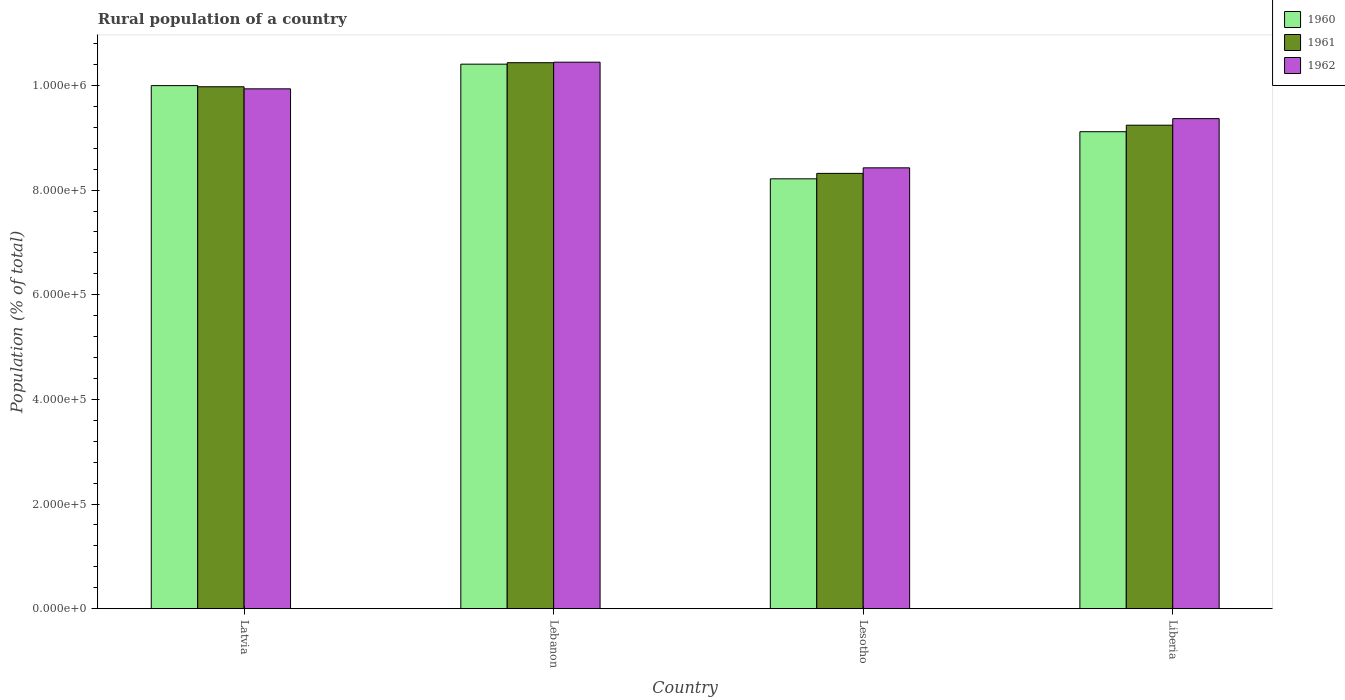How many bars are there on the 2nd tick from the right?
Make the answer very short. 3. What is the label of the 4th group of bars from the left?
Your response must be concise. Liberia. What is the rural population in 1962 in Lebanon?
Give a very brief answer. 1.04e+06. Across all countries, what is the maximum rural population in 1961?
Offer a very short reply. 1.04e+06. Across all countries, what is the minimum rural population in 1961?
Your answer should be very brief. 8.32e+05. In which country was the rural population in 1962 maximum?
Your response must be concise. Lebanon. In which country was the rural population in 1961 minimum?
Give a very brief answer. Lesotho. What is the total rural population in 1962 in the graph?
Provide a succinct answer. 3.82e+06. What is the difference between the rural population in 1961 in Lebanon and that in Liberia?
Offer a terse response. 1.19e+05. What is the difference between the rural population in 1961 in Latvia and the rural population in 1962 in Lebanon?
Offer a terse response. -4.69e+04. What is the average rural population in 1960 per country?
Keep it short and to the point. 9.43e+05. What is the difference between the rural population of/in 1962 and rural population of/in 1961 in Liberia?
Offer a terse response. 1.25e+04. What is the ratio of the rural population in 1960 in Latvia to that in Liberia?
Your response must be concise. 1.1. What is the difference between the highest and the second highest rural population in 1962?
Your response must be concise. 5.09e+04. What is the difference between the highest and the lowest rural population in 1960?
Provide a succinct answer. 2.19e+05. What does the 2nd bar from the left in Latvia represents?
Keep it short and to the point. 1961. What does the 2nd bar from the right in Lesotho represents?
Make the answer very short. 1961. Is it the case that in every country, the sum of the rural population in 1961 and rural population in 1962 is greater than the rural population in 1960?
Your answer should be compact. Yes. How many countries are there in the graph?
Offer a terse response. 4. Where does the legend appear in the graph?
Provide a succinct answer. Top right. How many legend labels are there?
Your answer should be compact. 3. What is the title of the graph?
Offer a terse response. Rural population of a country. Does "2009" appear as one of the legend labels in the graph?
Offer a terse response. No. What is the label or title of the Y-axis?
Your answer should be compact. Population (% of total). What is the Population (% of total) in 1960 in Latvia?
Make the answer very short. 1.00e+06. What is the Population (% of total) in 1961 in Latvia?
Your response must be concise. 9.97e+05. What is the Population (% of total) of 1962 in Latvia?
Provide a succinct answer. 9.94e+05. What is the Population (% of total) of 1960 in Lebanon?
Your answer should be very brief. 1.04e+06. What is the Population (% of total) in 1961 in Lebanon?
Provide a short and direct response. 1.04e+06. What is the Population (% of total) of 1962 in Lebanon?
Give a very brief answer. 1.04e+06. What is the Population (% of total) of 1960 in Lesotho?
Offer a very short reply. 8.22e+05. What is the Population (% of total) of 1961 in Lesotho?
Your answer should be very brief. 8.32e+05. What is the Population (% of total) of 1962 in Lesotho?
Make the answer very short. 8.43e+05. What is the Population (% of total) of 1960 in Liberia?
Ensure brevity in your answer.  9.12e+05. What is the Population (% of total) of 1961 in Liberia?
Your answer should be very brief. 9.24e+05. What is the Population (% of total) of 1962 in Liberia?
Offer a very short reply. 9.37e+05. Across all countries, what is the maximum Population (% of total) of 1960?
Keep it short and to the point. 1.04e+06. Across all countries, what is the maximum Population (% of total) of 1961?
Ensure brevity in your answer.  1.04e+06. Across all countries, what is the maximum Population (% of total) in 1962?
Make the answer very short. 1.04e+06. Across all countries, what is the minimum Population (% of total) in 1960?
Keep it short and to the point. 8.22e+05. Across all countries, what is the minimum Population (% of total) of 1961?
Your response must be concise. 8.32e+05. Across all countries, what is the minimum Population (% of total) of 1962?
Provide a succinct answer. 8.43e+05. What is the total Population (% of total) in 1960 in the graph?
Provide a short and direct response. 3.77e+06. What is the total Population (% of total) in 1961 in the graph?
Offer a terse response. 3.80e+06. What is the total Population (% of total) of 1962 in the graph?
Provide a short and direct response. 3.82e+06. What is the difference between the Population (% of total) in 1960 in Latvia and that in Lebanon?
Provide a short and direct response. -4.10e+04. What is the difference between the Population (% of total) of 1961 in Latvia and that in Lebanon?
Provide a succinct answer. -4.60e+04. What is the difference between the Population (% of total) of 1962 in Latvia and that in Lebanon?
Offer a terse response. -5.09e+04. What is the difference between the Population (% of total) in 1960 in Latvia and that in Lesotho?
Provide a short and direct response. 1.78e+05. What is the difference between the Population (% of total) in 1961 in Latvia and that in Lesotho?
Offer a terse response. 1.66e+05. What is the difference between the Population (% of total) in 1962 in Latvia and that in Lesotho?
Your answer should be compact. 1.51e+05. What is the difference between the Population (% of total) of 1960 in Latvia and that in Liberia?
Offer a terse response. 8.81e+04. What is the difference between the Population (% of total) in 1961 in Latvia and that in Liberia?
Keep it short and to the point. 7.35e+04. What is the difference between the Population (% of total) of 1962 in Latvia and that in Liberia?
Your response must be concise. 5.69e+04. What is the difference between the Population (% of total) of 1960 in Lebanon and that in Lesotho?
Offer a very short reply. 2.19e+05. What is the difference between the Population (% of total) of 1961 in Lebanon and that in Lesotho?
Provide a short and direct response. 2.12e+05. What is the difference between the Population (% of total) of 1962 in Lebanon and that in Lesotho?
Offer a terse response. 2.02e+05. What is the difference between the Population (% of total) of 1960 in Lebanon and that in Liberia?
Make the answer very short. 1.29e+05. What is the difference between the Population (% of total) of 1961 in Lebanon and that in Liberia?
Offer a terse response. 1.19e+05. What is the difference between the Population (% of total) in 1962 in Lebanon and that in Liberia?
Offer a terse response. 1.08e+05. What is the difference between the Population (% of total) in 1960 in Lesotho and that in Liberia?
Keep it short and to the point. -9.01e+04. What is the difference between the Population (% of total) in 1961 in Lesotho and that in Liberia?
Give a very brief answer. -9.21e+04. What is the difference between the Population (% of total) of 1962 in Lesotho and that in Liberia?
Keep it short and to the point. -9.40e+04. What is the difference between the Population (% of total) of 1960 in Latvia and the Population (% of total) of 1961 in Lebanon?
Offer a terse response. -4.38e+04. What is the difference between the Population (% of total) in 1960 in Latvia and the Population (% of total) in 1962 in Lebanon?
Your response must be concise. -4.47e+04. What is the difference between the Population (% of total) in 1961 in Latvia and the Population (% of total) in 1962 in Lebanon?
Your response must be concise. -4.69e+04. What is the difference between the Population (% of total) in 1960 in Latvia and the Population (% of total) in 1961 in Lesotho?
Ensure brevity in your answer.  1.68e+05. What is the difference between the Population (% of total) of 1960 in Latvia and the Population (% of total) of 1962 in Lesotho?
Ensure brevity in your answer.  1.57e+05. What is the difference between the Population (% of total) in 1961 in Latvia and the Population (% of total) in 1962 in Lesotho?
Ensure brevity in your answer.  1.55e+05. What is the difference between the Population (% of total) of 1960 in Latvia and the Population (% of total) of 1961 in Liberia?
Make the answer very short. 7.56e+04. What is the difference between the Population (% of total) in 1960 in Latvia and the Population (% of total) in 1962 in Liberia?
Provide a short and direct response. 6.31e+04. What is the difference between the Population (% of total) in 1961 in Latvia and the Population (% of total) in 1962 in Liberia?
Offer a terse response. 6.09e+04. What is the difference between the Population (% of total) in 1960 in Lebanon and the Population (% of total) in 1961 in Lesotho?
Provide a succinct answer. 2.09e+05. What is the difference between the Population (% of total) of 1960 in Lebanon and the Population (% of total) of 1962 in Lesotho?
Provide a succinct answer. 1.98e+05. What is the difference between the Population (% of total) of 1961 in Lebanon and the Population (% of total) of 1962 in Lesotho?
Keep it short and to the point. 2.01e+05. What is the difference between the Population (% of total) of 1960 in Lebanon and the Population (% of total) of 1961 in Liberia?
Make the answer very short. 1.17e+05. What is the difference between the Population (% of total) of 1960 in Lebanon and the Population (% of total) of 1962 in Liberia?
Your answer should be compact. 1.04e+05. What is the difference between the Population (% of total) of 1961 in Lebanon and the Population (% of total) of 1962 in Liberia?
Provide a short and direct response. 1.07e+05. What is the difference between the Population (% of total) of 1960 in Lesotho and the Population (% of total) of 1961 in Liberia?
Your response must be concise. -1.03e+05. What is the difference between the Population (% of total) in 1960 in Lesotho and the Population (% of total) in 1962 in Liberia?
Give a very brief answer. -1.15e+05. What is the difference between the Population (% of total) of 1961 in Lesotho and the Population (% of total) of 1962 in Liberia?
Make the answer very short. -1.05e+05. What is the average Population (% of total) in 1960 per country?
Provide a short and direct response. 9.43e+05. What is the average Population (% of total) in 1961 per country?
Keep it short and to the point. 9.49e+05. What is the average Population (% of total) in 1962 per country?
Ensure brevity in your answer.  9.54e+05. What is the difference between the Population (% of total) in 1960 and Population (% of total) in 1961 in Latvia?
Offer a very short reply. 2193. What is the difference between the Population (% of total) in 1960 and Population (% of total) in 1962 in Latvia?
Your answer should be compact. 6165. What is the difference between the Population (% of total) in 1961 and Population (% of total) in 1962 in Latvia?
Make the answer very short. 3972. What is the difference between the Population (% of total) of 1960 and Population (% of total) of 1961 in Lebanon?
Your answer should be compact. -2785. What is the difference between the Population (% of total) of 1960 and Population (% of total) of 1962 in Lebanon?
Your answer should be very brief. -3757. What is the difference between the Population (% of total) in 1961 and Population (% of total) in 1962 in Lebanon?
Provide a short and direct response. -972. What is the difference between the Population (% of total) in 1960 and Population (% of total) in 1961 in Lesotho?
Provide a short and direct response. -1.04e+04. What is the difference between the Population (% of total) in 1960 and Population (% of total) in 1962 in Lesotho?
Your answer should be compact. -2.10e+04. What is the difference between the Population (% of total) in 1961 and Population (% of total) in 1962 in Lesotho?
Your answer should be compact. -1.06e+04. What is the difference between the Population (% of total) of 1960 and Population (% of total) of 1961 in Liberia?
Keep it short and to the point. -1.25e+04. What is the difference between the Population (% of total) in 1960 and Population (% of total) in 1962 in Liberia?
Your answer should be compact. -2.50e+04. What is the difference between the Population (% of total) of 1961 and Population (% of total) of 1962 in Liberia?
Offer a terse response. -1.25e+04. What is the ratio of the Population (% of total) of 1960 in Latvia to that in Lebanon?
Offer a terse response. 0.96. What is the ratio of the Population (% of total) of 1961 in Latvia to that in Lebanon?
Provide a succinct answer. 0.96. What is the ratio of the Population (% of total) in 1962 in Latvia to that in Lebanon?
Give a very brief answer. 0.95. What is the ratio of the Population (% of total) of 1960 in Latvia to that in Lesotho?
Your answer should be very brief. 1.22. What is the ratio of the Population (% of total) of 1961 in Latvia to that in Lesotho?
Provide a succinct answer. 1.2. What is the ratio of the Population (% of total) of 1962 in Latvia to that in Lesotho?
Provide a short and direct response. 1.18. What is the ratio of the Population (% of total) of 1960 in Latvia to that in Liberia?
Offer a terse response. 1.1. What is the ratio of the Population (% of total) in 1961 in Latvia to that in Liberia?
Your answer should be very brief. 1.08. What is the ratio of the Population (% of total) in 1962 in Latvia to that in Liberia?
Keep it short and to the point. 1.06. What is the ratio of the Population (% of total) in 1960 in Lebanon to that in Lesotho?
Your response must be concise. 1.27. What is the ratio of the Population (% of total) of 1961 in Lebanon to that in Lesotho?
Your response must be concise. 1.25. What is the ratio of the Population (% of total) of 1962 in Lebanon to that in Lesotho?
Provide a succinct answer. 1.24. What is the ratio of the Population (% of total) of 1960 in Lebanon to that in Liberia?
Ensure brevity in your answer.  1.14. What is the ratio of the Population (% of total) in 1961 in Lebanon to that in Liberia?
Give a very brief answer. 1.13. What is the ratio of the Population (% of total) of 1962 in Lebanon to that in Liberia?
Keep it short and to the point. 1.12. What is the ratio of the Population (% of total) of 1960 in Lesotho to that in Liberia?
Make the answer very short. 0.9. What is the ratio of the Population (% of total) of 1961 in Lesotho to that in Liberia?
Keep it short and to the point. 0.9. What is the ratio of the Population (% of total) in 1962 in Lesotho to that in Liberia?
Your response must be concise. 0.9. What is the difference between the highest and the second highest Population (% of total) in 1960?
Make the answer very short. 4.10e+04. What is the difference between the highest and the second highest Population (% of total) of 1961?
Your response must be concise. 4.60e+04. What is the difference between the highest and the second highest Population (% of total) of 1962?
Your answer should be compact. 5.09e+04. What is the difference between the highest and the lowest Population (% of total) in 1960?
Your answer should be compact. 2.19e+05. What is the difference between the highest and the lowest Population (% of total) of 1961?
Give a very brief answer. 2.12e+05. What is the difference between the highest and the lowest Population (% of total) of 1962?
Make the answer very short. 2.02e+05. 